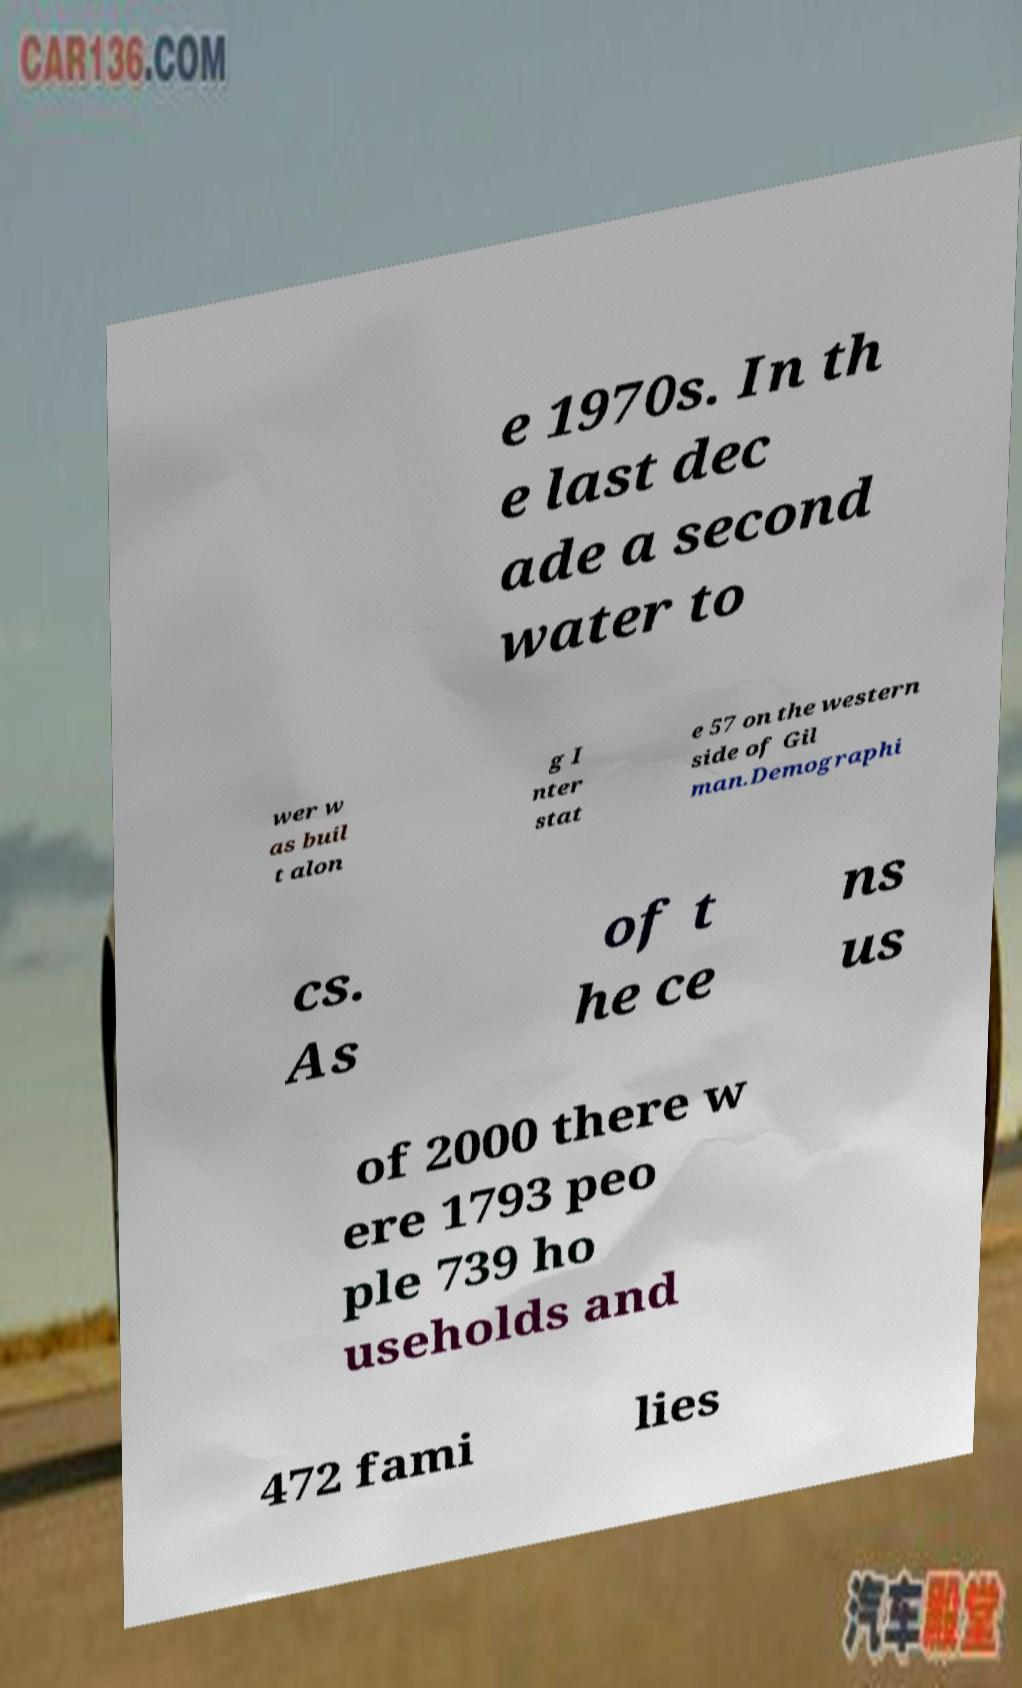What messages or text are displayed in this image? I need them in a readable, typed format. e 1970s. In th e last dec ade a second water to wer w as buil t alon g I nter stat e 57 on the western side of Gil man.Demographi cs. As of t he ce ns us of 2000 there w ere 1793 peo ple 739 ho useholds and 472 fami lies 